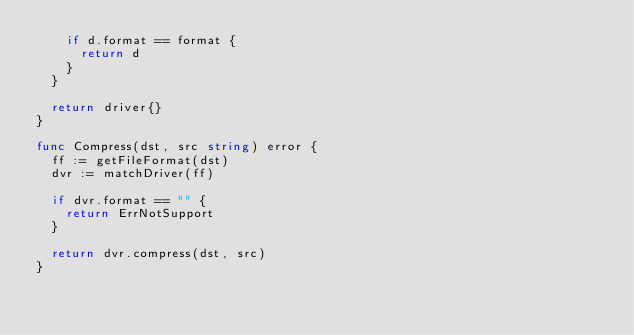<code> <loc_0><loc_0><loc_500><loc_500><_Go_>		if d.format == format {
			return d
		}
	}

	return driver{}
}

func Compress(dst, src string) error {
	ff := getFileFormat(dst)
	dvr := matchDriver(ff)

	if dvr.format == "" {
		return ErrNotSupport
	}

	return dvr.compress(dst, src)
}
</code> 